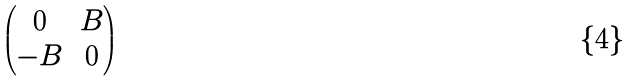Convert formula to latex. <formula><loc_0><loc_0><loc_500><loc_500>\begin{pmatrix} 0 & B \\ - B & 0 \end{pmatrix}</formula> 